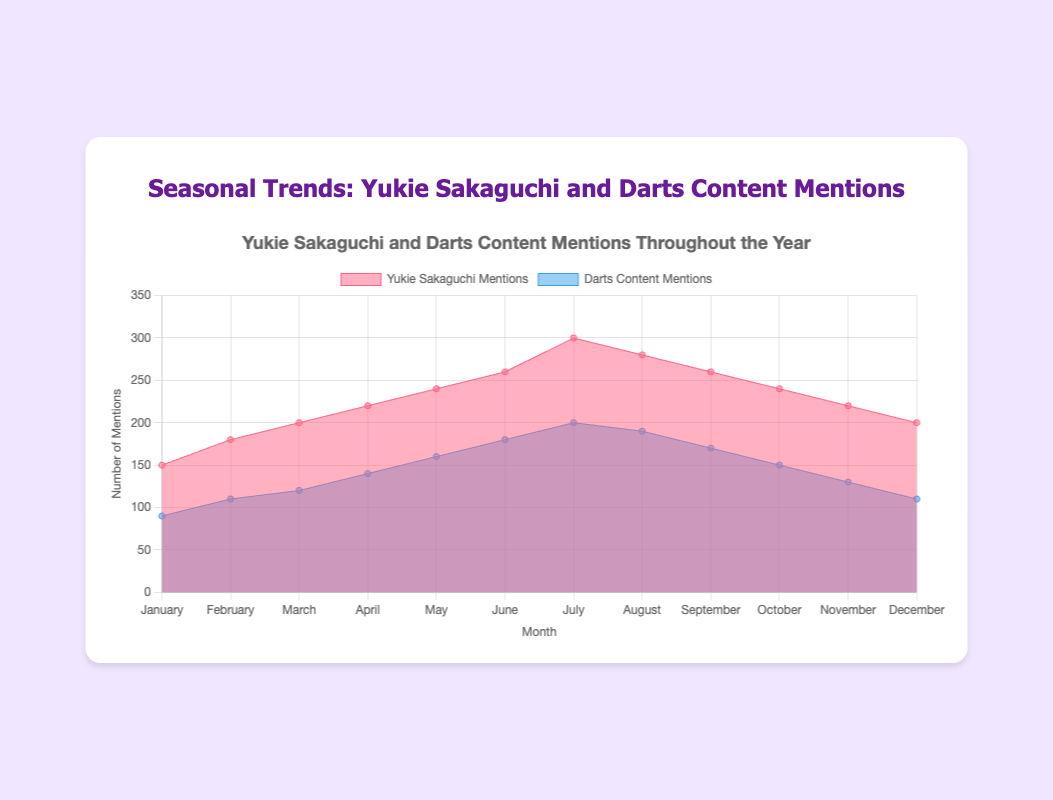What is the title of the chart? The title is displayed at the top of the chart. By reading there, we can identify the chart's title.
Answer: Seasonal Trends: Yukie Sakaguchi and Darts Content Mentions What is the highest number of mentions for Yukie Sakaguchi in a single month? By looking at the series labeled 'Yukie Sakaguchi Mentions' and finding the peak point, we see that the highest number of mentions occurs in July at 300.
Answer: 300 In which month does Darts Content have the lowest mentions? We look at the series labeled 'Darts Content Mentions' and identify the lowest point, which appears in January at 90.
Answer: January How do mentions of Yukie Sakaguchi change from January to July? From January to July, we look at the Yukie Sakaguchi mentions and note the trend. The mentions start at 150 in January and increase to 300 in July. The change is an increase of 150.
Answer: Increase by 150 Which month has the smallest difference between Yukie Sakaguchi and Darts Content mentions? We calculate the difference for each month by subtracting Darts Content mentions from Yukie Sakaguchi mentions. April has the smallest difference (220-140=80).
Answer: April What is the total number of mentions for Yukie Sakaguchi from January to June? We sum up the mentions for Yukie Sakaguchi from January to June (150 + 180 + 200 + 220 + 240 + 260) which equals 1250.
Answer: 1250 Which month sees the highest combined mentions of Yukie Sakaguchi and Darts Content? By adding up the mentions for both Yukie Sakaguchi and Darts Content for each month, the highest combined total is in July (300 + 200 = 500).
Answer: July How many months have more than 200 mentions for Yukie Sakaguchi? By counting the months where the number of mentions for Yukie Sakaguchi exceeds 200, we find there are seven such months: April, May, June, July, August, September, October.
Answer: 7 What is the average monthly mention for Darts Content over the year? We calculate the average by summing up all monthly mentions and dividing by 12. Total mentions are 1800, so the average is 1800 / 12 = 150.
Answer: 150 In which month does Yukie Sakaguchi's mentions decrease for the first time? We compare the monthly mentions and see that the first decrease happens from July (300) to August (280).
Answer: August 